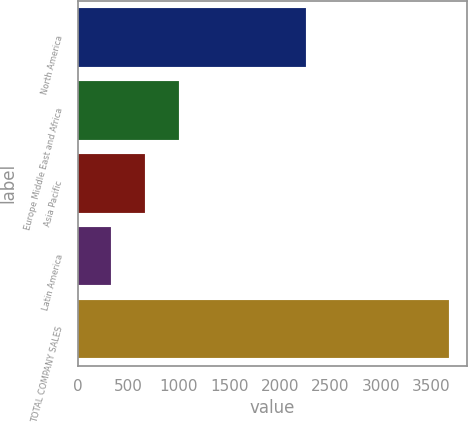<chart> <loc_0><loc_0><loc_500><loc_500><bar_chart><fcel>North America<fcel>Europe Middle East and Africa<fcel>Asia Pacific<fcel>Latin America<fcel>TOTAL COMPANY SALES<nl><fcel>2262.2<fcel>1000.9<fcel>666.9<fcel>332.9<fcel>3672.9<nl></chart> 